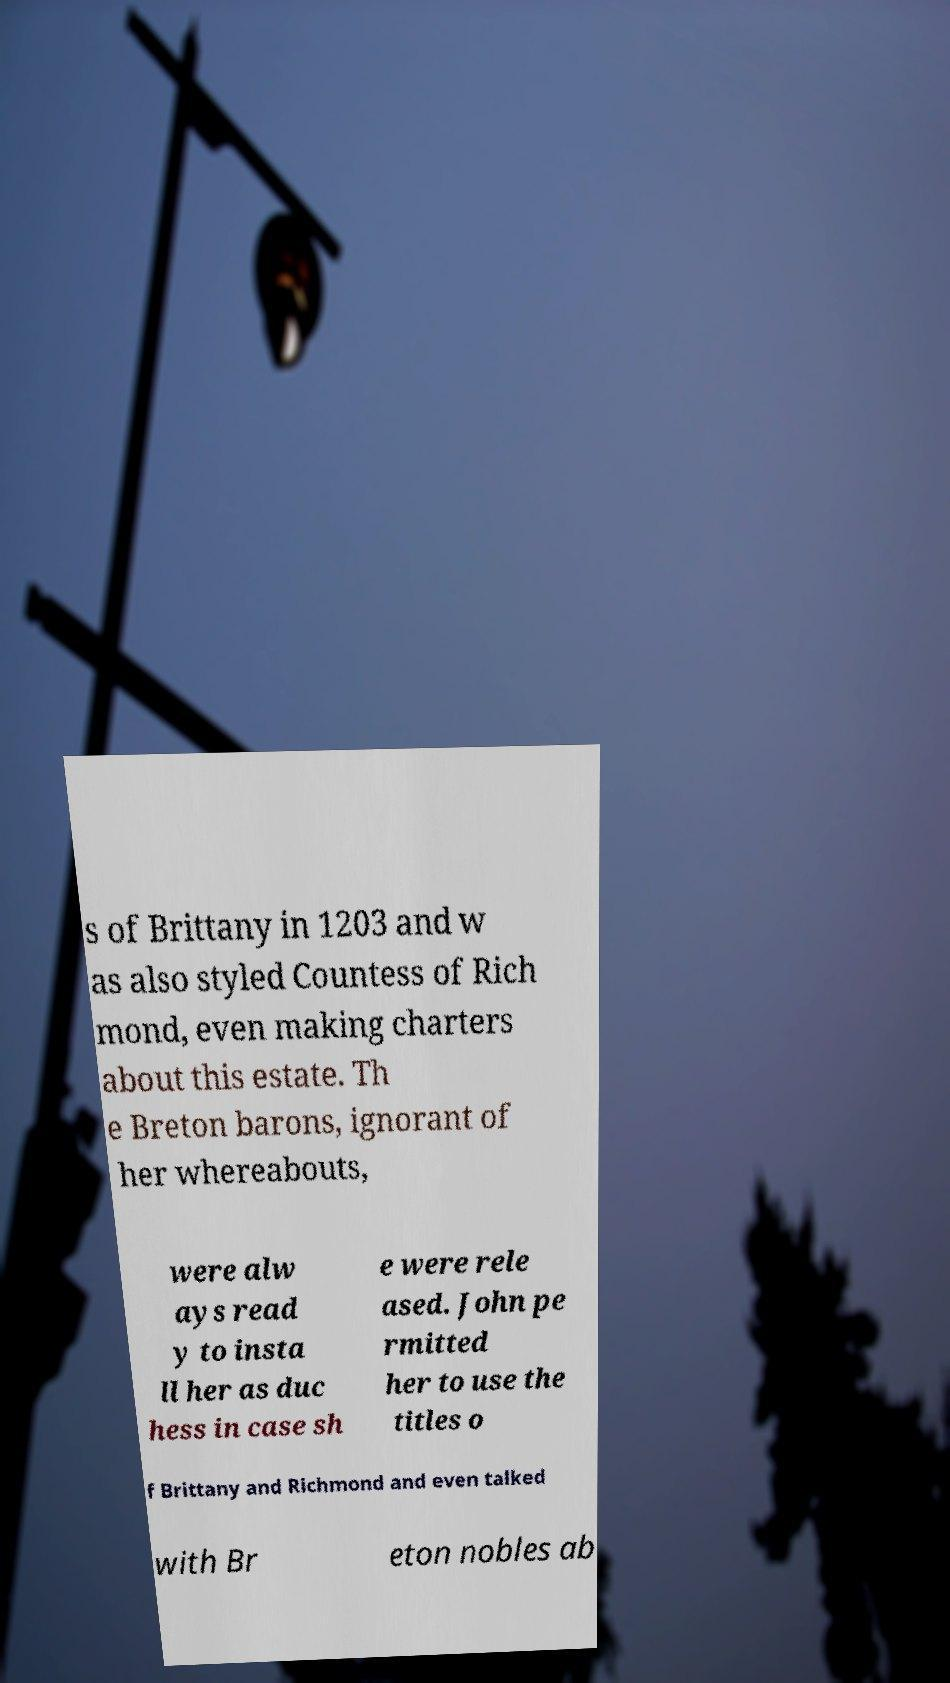What messages or text are displayed in this image? I need them in a readable, typed format. s of Brittany in 1203 and w as also styled Countess of Rich mond, even making charters about this estate. Th e Breton barons, ignorant of her whereabouts, were alw ays read y to insta ll her as duc hess in case sh e were rele ased. John pe rmitted her to use the titles o f Brittany and Richmond and even talked with Br eton nobles ab 